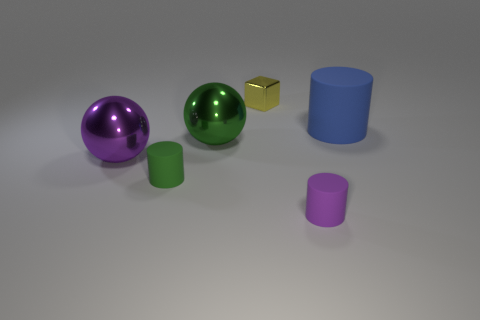Can you tell me which objects seem to have reflective surfaces? The purple and green balls have reflective surfaces, evident by the slight glare on them and the visible reflections of the enviornment. 